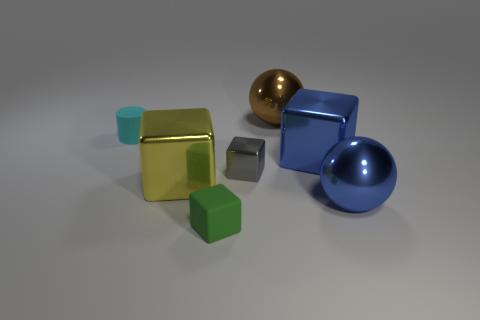Subtract all small metal blocks. How many blocks are left? 3 Subtract all red blocks. Subtract all blue cylinders. How many blocks are left? 4 Subtract all red spheres. How many brown cylinders are left? 0 Subtract all green matte cubes. Subtract all cyan rubber cubes. How many objects are left? 6 Add 6 tiny gray things. How many tiny gray things are left? 7 Add 1 yellow metallic cubes. How many yellow metallic cubes exist? 2 Add 3 tiny yellow metal balls. How many objects exist? 10 Subtract all blue blocks. How many blocks are left? 3 Subtract 0 red blocks. How many objects are left? 7 Subtract all cylinders. How many objects are left? 6 